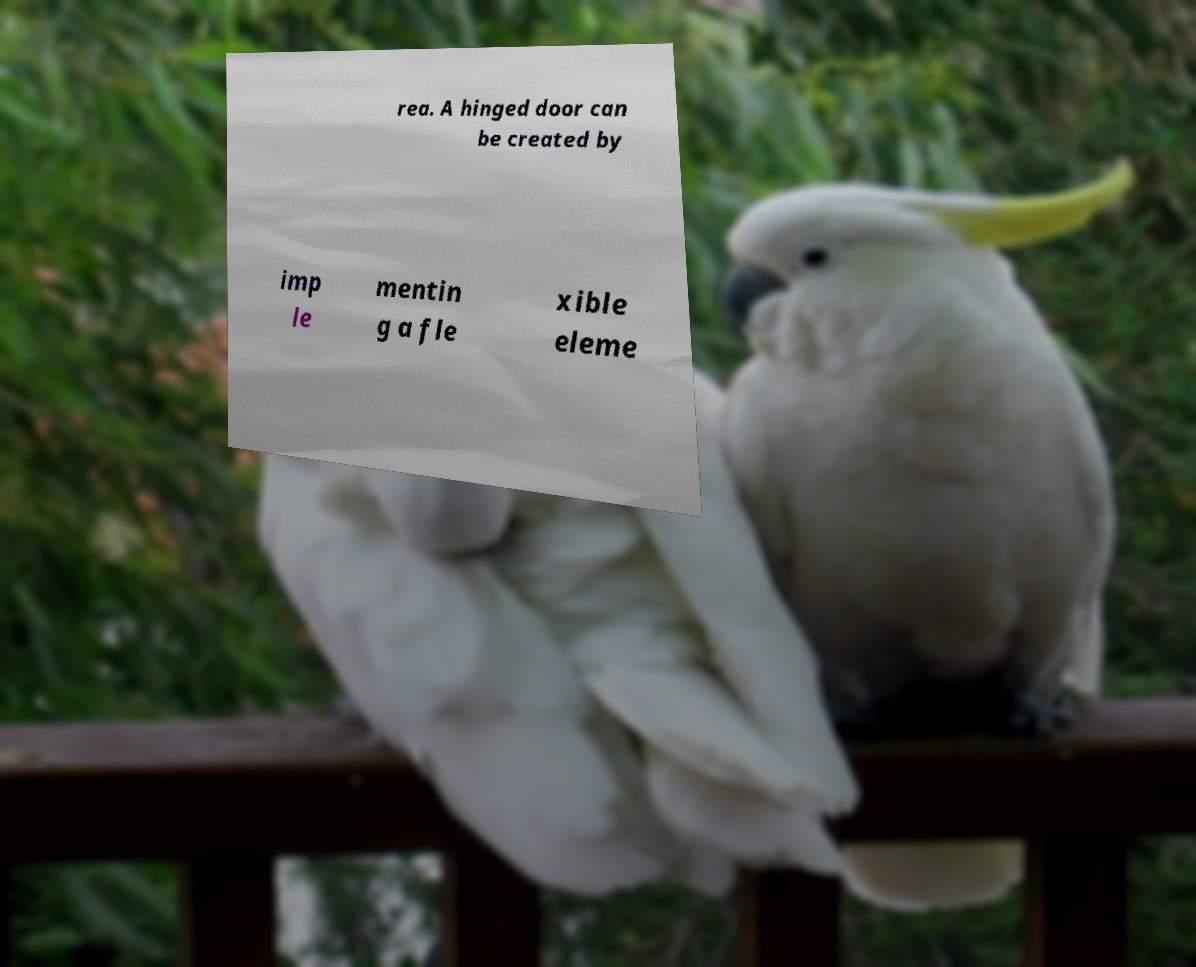For documentation purposes, I need the text within this image transcribed. Could you provide that? rea. A hinged door can be created by imp le mentin g a fle xible eleme 